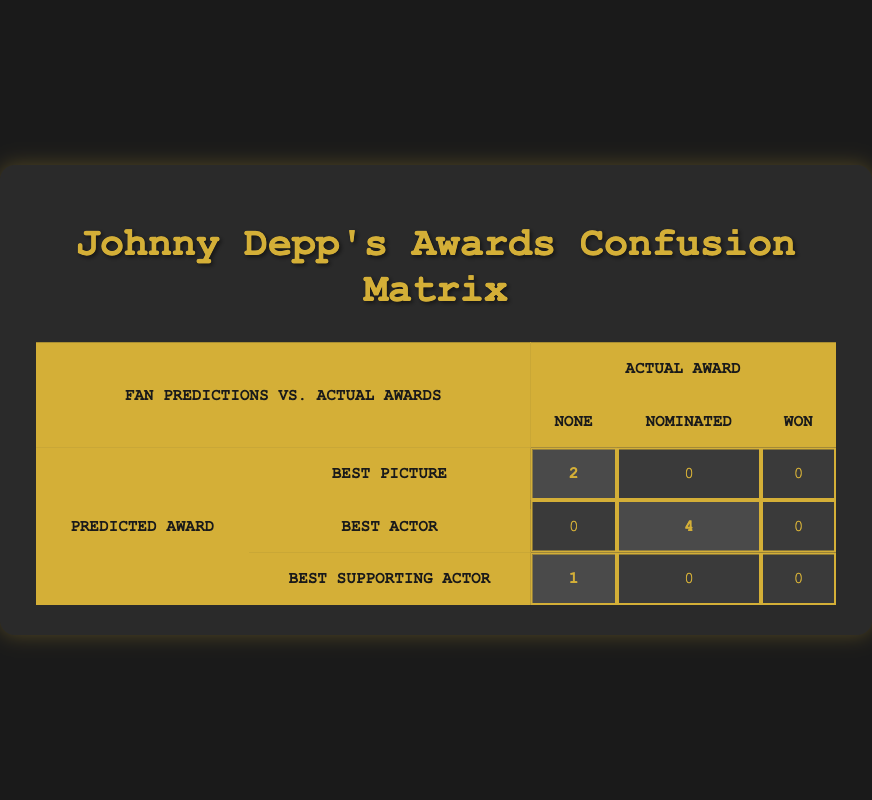What predicted award type had the highest number of correct predictions for "None"? Looking at the row for "Best Picture," we see that there are 2 predictions for that award type, which is the highest count under the "None" category compared to the others. The "Best Supporting Actor" has 1, while "Best Actor" has 0.
Answer: Best Picture How many movies did Johnny Depp receive nominations for under the "Best Actor" predicted category? In the "Best Actor" row, we see that there are 4 movies that fall under the "Nominated" category.
Answer: 4 Is it true that Johnny Depp's movies predicted for "Best Supporting Actor" had more wins than those predicted for "Best Picture"? Based on the data, there are 0 wins for both "Best Supporting Actor" and "Best Picture," thus the statement is false.
Answer: No What is the total number of movies that were predicted as "Best Picture"? By looking at the "Best Picture" row, we see there are 2 correct predictions that resulted in "None," so the total number is 2.
Answer: 2 If we combine predictions for movies that got nominated as "Best Actor" and "Best Supporting Actor", what is the total number of nominations? Adding the nominations from "Best Actor" (4) and "Best Supporting Actor" (0), the total is 4.
Answer: 4 